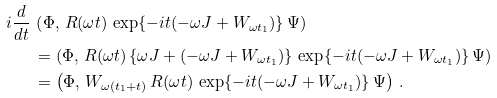<formula> <loc_0><loc_0><loc_500><loc_500>i \frac { d } { d t } \, & \left ( \Phi , \, R ( \omega t ) \, \exp \{ - i t ( - \omega J + W _ { \omega t _ { 1 } } ) \} \, \Psi \right ) \\ & = \left ( \Phi , \, R ( \omega t ) \, \{ \omega J + ( - \omega J + W _ { \omega t _ { 1 } } ) \} \, \exp \{ - i t ( - \omega J + W _ { \omega t _ { 1 } } ) \} \, \Psi \right ) \\ & = \left ( \Phi , \, W _ { \omega ( t _ { 1 } + t ) } \, R ( \omega t ) \, \exp \{ - i t ( - \omega J + W _ { \omega t _ { 1 } } ) \} \, \Psi \right ) \, .</formula> 